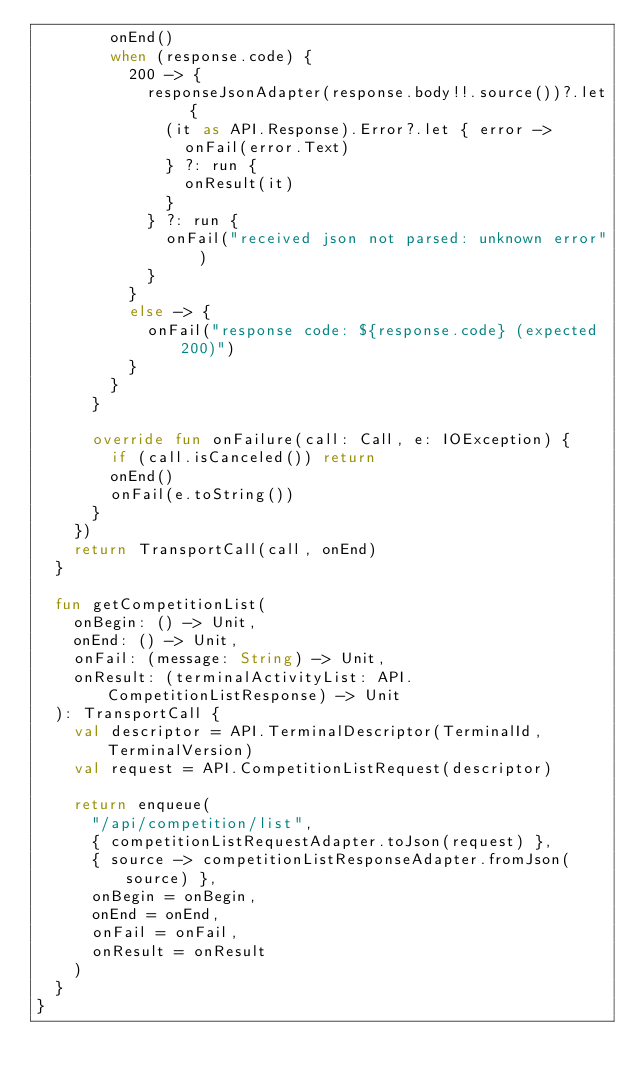<code> <loc_0><loc_0><loc_500><loc_500><_Kotlin_>        onEnd()
        when (response.code) {
          200 -> {
            responseJsonAdapter(response.body!!.source())?.let {
              (it as API.Response).Error?.let { error ->
                onFail(error.Text)
              } ?: run {
                onResult(it)
              }
            } ?: run {
              onFail("received json not parsed: unknown error")
            }
          }
          else -> {
            onFail("response code: ${response.code} (expected 200)")
          }
        }
      }

      override fun onFailure(call: Call, e: IOException) {
        if (call.isCanceled()) return
        onEnd()
        onFail(e.toString())
      }
    })
    return TransportCall(call, onEnd)
  }

  fun getCompetitionList(
    onBegin: () -> Unit,
    onEnd: () -> Unit,
    onFail: (message: String) -> Unit,
    onResult: (terminalActivityList: API.CompetitionListResponse) -> Unit
  ): TransportCall {
    val descriptor = API.TerminalDescriptor(TerminalId, TerminalVersion)
    val request = API.CompetitionListRequest(descriptor)

    return enqueue(
      "/api/competition/list",
      { competitionListRequestAdapter.toJson(request) },
      { source -> competitionListResponseAdapter.fromJson(source) },
      onBegin = onBegin,
      onEnd = onEnd,
      onFail = onFail,
      onResult = onResult
    )
  }
}</code> 